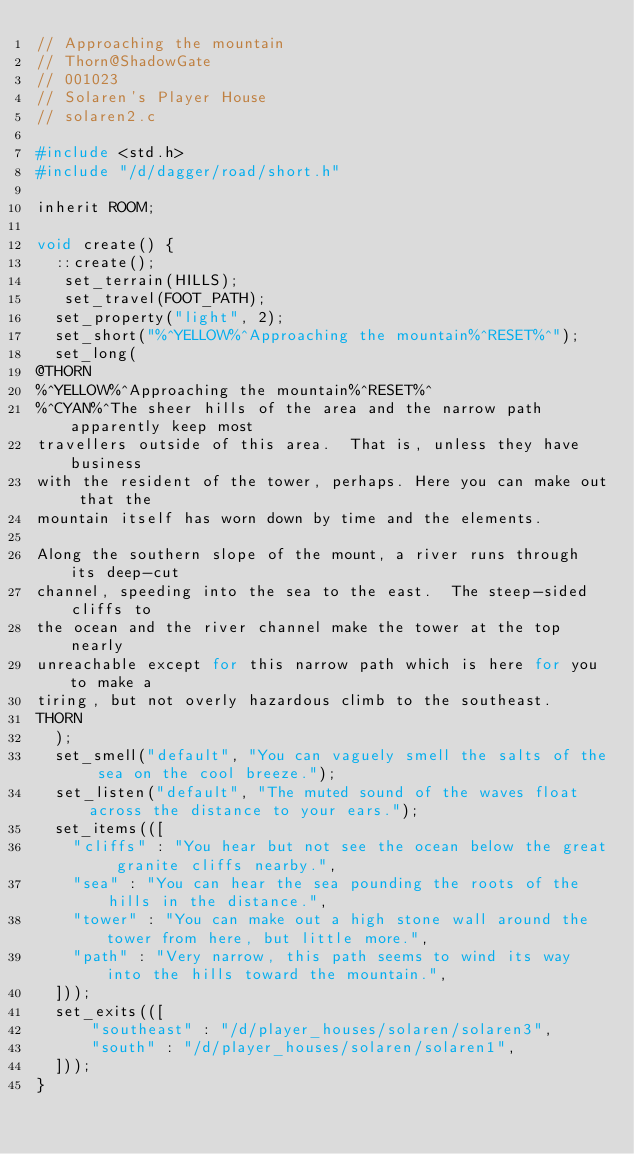<code> <loc_0><loc_0><loc_500><loc_500><_C_>// Approaching the mountain
// Thorn@ShadowGate
// 001023
// Solaren's Player House
// solaren2.c

#include <std.h>
#include "/d/dagger/road/short.h"

inherit ROOM;

void create() {
  ::create();
   set_terrain(HILLS);
   set_travel(FOOT_PATH);
  set_property("light", 2);
  set_short("%^YELLOW%^Approaching the mountain%^RESET%^");
  set_long(
@THORN
%^YELLOW%^Approaching the mountain%^RESET%^
%^CYAN%^The sheer hills of the area and the narrow path apparently keep most
travellers outside of this area.  That is, unless they have business
with the resident of the tower, perhaps. Here you can make out that the
mountain itself has worn down by time and the elements.

Along the southern slope of the mount, a river runs through its deep-cut
channel, speeding into the sea to the east.  The steep-sided cliffs to
the ocean and the river channel make the tower at the top nearly
unreachable except for this narrow path which is here for you to make a
tiring, but not overly hazardous climb to the southeast. 
THORN
  );
  set_smell("default", "You can vaguely smell the salts of the sea on the cool breeze.");
  set_listen("default", "The muted sound of the waves float across the distance to your ears.");
  set_items(([
    "cliffs" : "You hear but not see the ocean below the great granite cliffs nearby.",
    "sea" : "You can hear the sea pounding the roots of the hills in the distance.",
    "tower" : "You can make out a high stone wall around the tower from here, but little more.",
    "path" : "Very narrow, this path seems to wind its way into the hills toward the mountain.",
  ]));
  set_exits(([
      "southeast" : "/d/player_houses/solaren/solaren3",
      "south" : "/d/player_houses/solaren/solaren1",
  ]));
}
</code> 